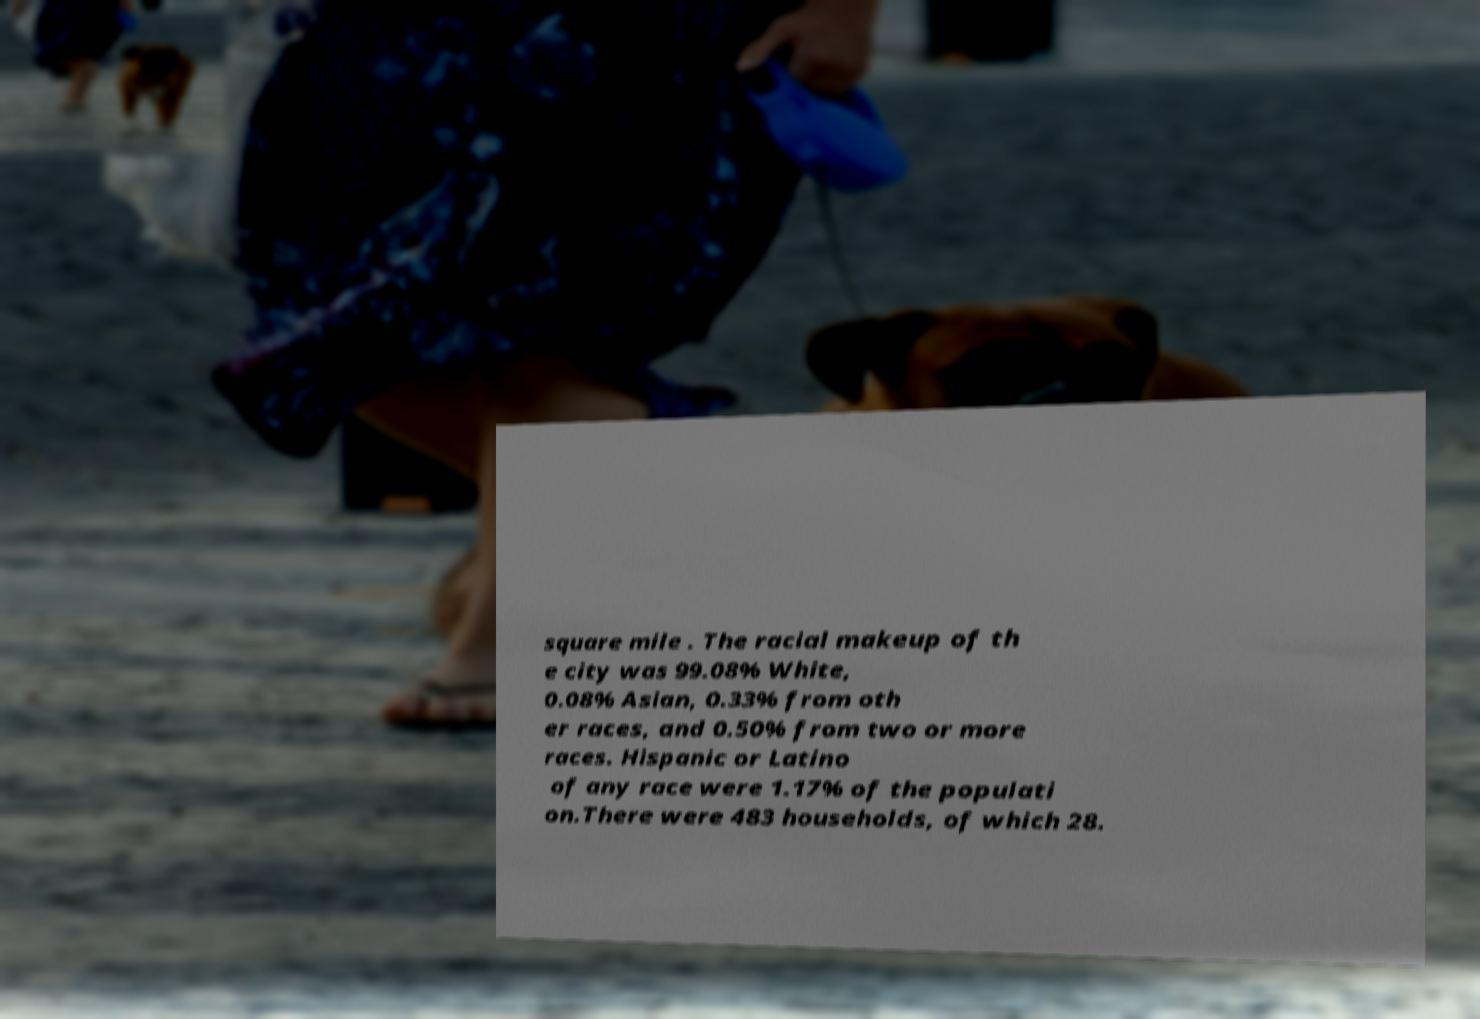Please read and relay the text visible in this image. What does it say? square mile . The racial makeup of th e city was 99.08% White, 0.08% Asian, 0.33% from oth er races, and 0.50% from two or more races. Hispanic or Latino of any race were 1.17% of the populati on.There were 483 households, of which 28. 